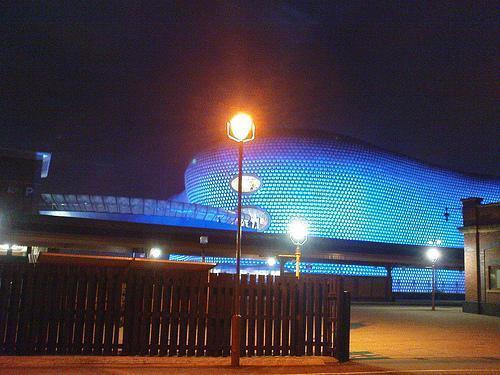How many street lights can you see?
Give a very brief answer. 5. 